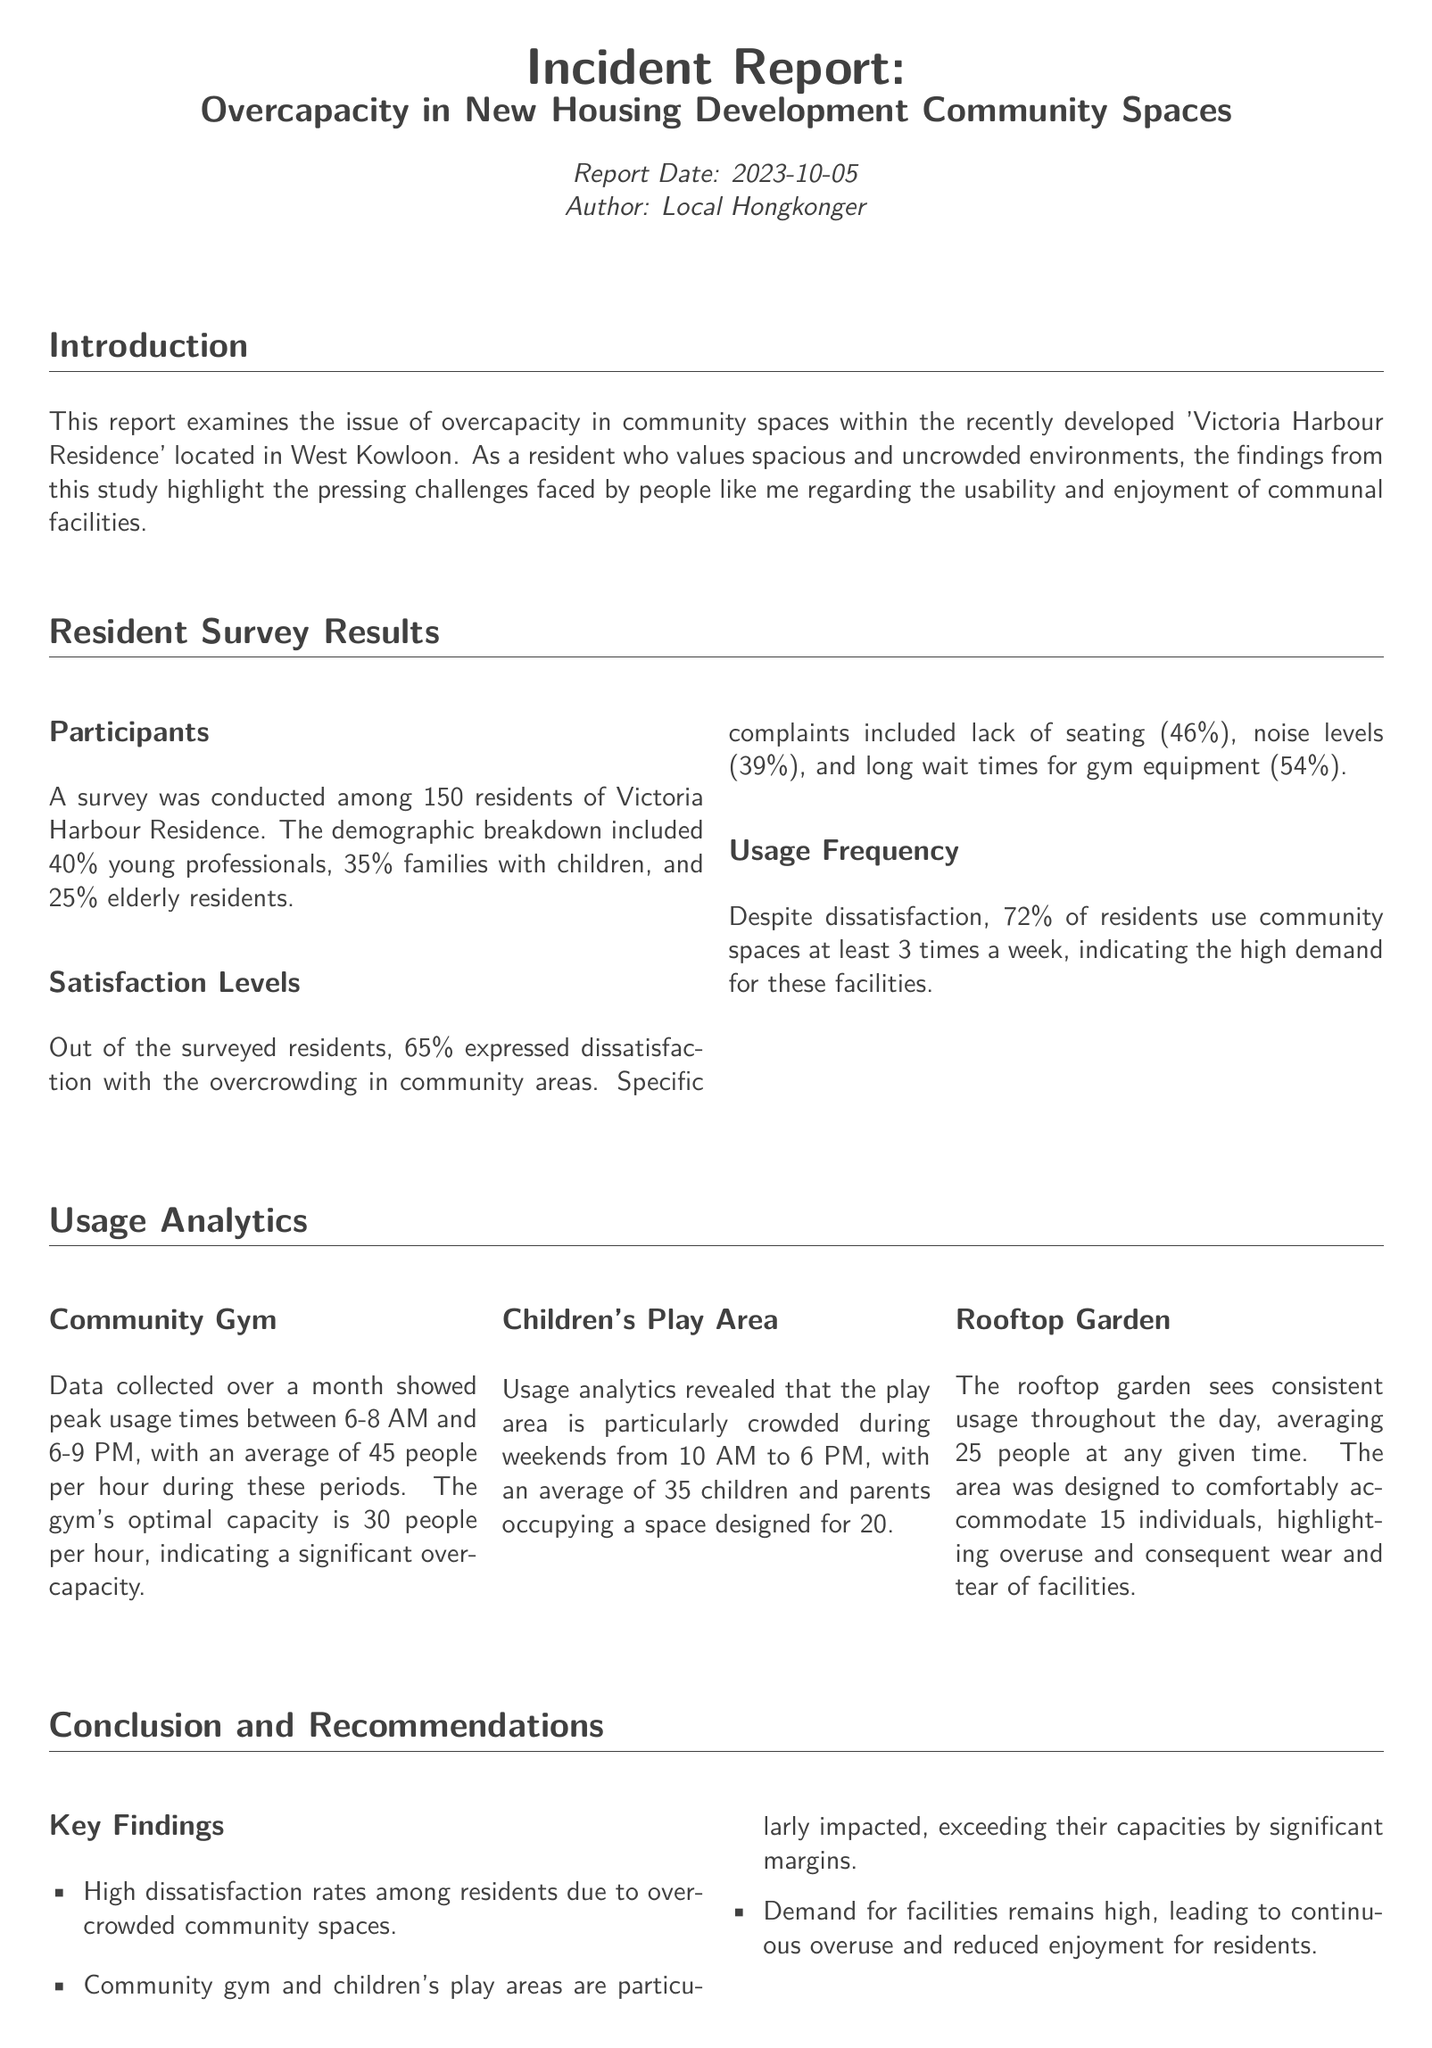what percentage of residents expressed dissatisfaction with overcrowding? The document states that 65% of residents expressed dissatisfaction with the overcrowding in community areas.
Answer: 65% what was the optimal capacity of the community gym? It mentions that the gym's optimal capacity is 30 people per hour.
Answer: 30 how many children and parents typically occupy the children's play area? The document reveals that the play area averages 35 children and parents but is designed for 20.
Answer: 35 what are the peak usage times for the community gym? The peak usage times for the gym are between 6-8 AM and 6-9 PM.
Answer: 6-8 AM and 6-9 PM what is the average number of people using the rooftop garden? The average usage of the rooftop garden is 25 people at any given time.
Answer: 25 which group of residents has the highest percentage? The demographic breakdown shows that 40% are young professionals, which is the highest percentage.
Answer: young professionals what recommendation was made regarding reservation systems? The report recommends implementing reservation systems during peak times.
Answer: implement reservation systems what was the date of the report? The report date is clearly stated to be 2023-10-05.
Answer: 2023-10-05 how many residents were surveyed in total? The survey was conducted among 150 residents of Victoria Harbour Residence.
Answer: 150 